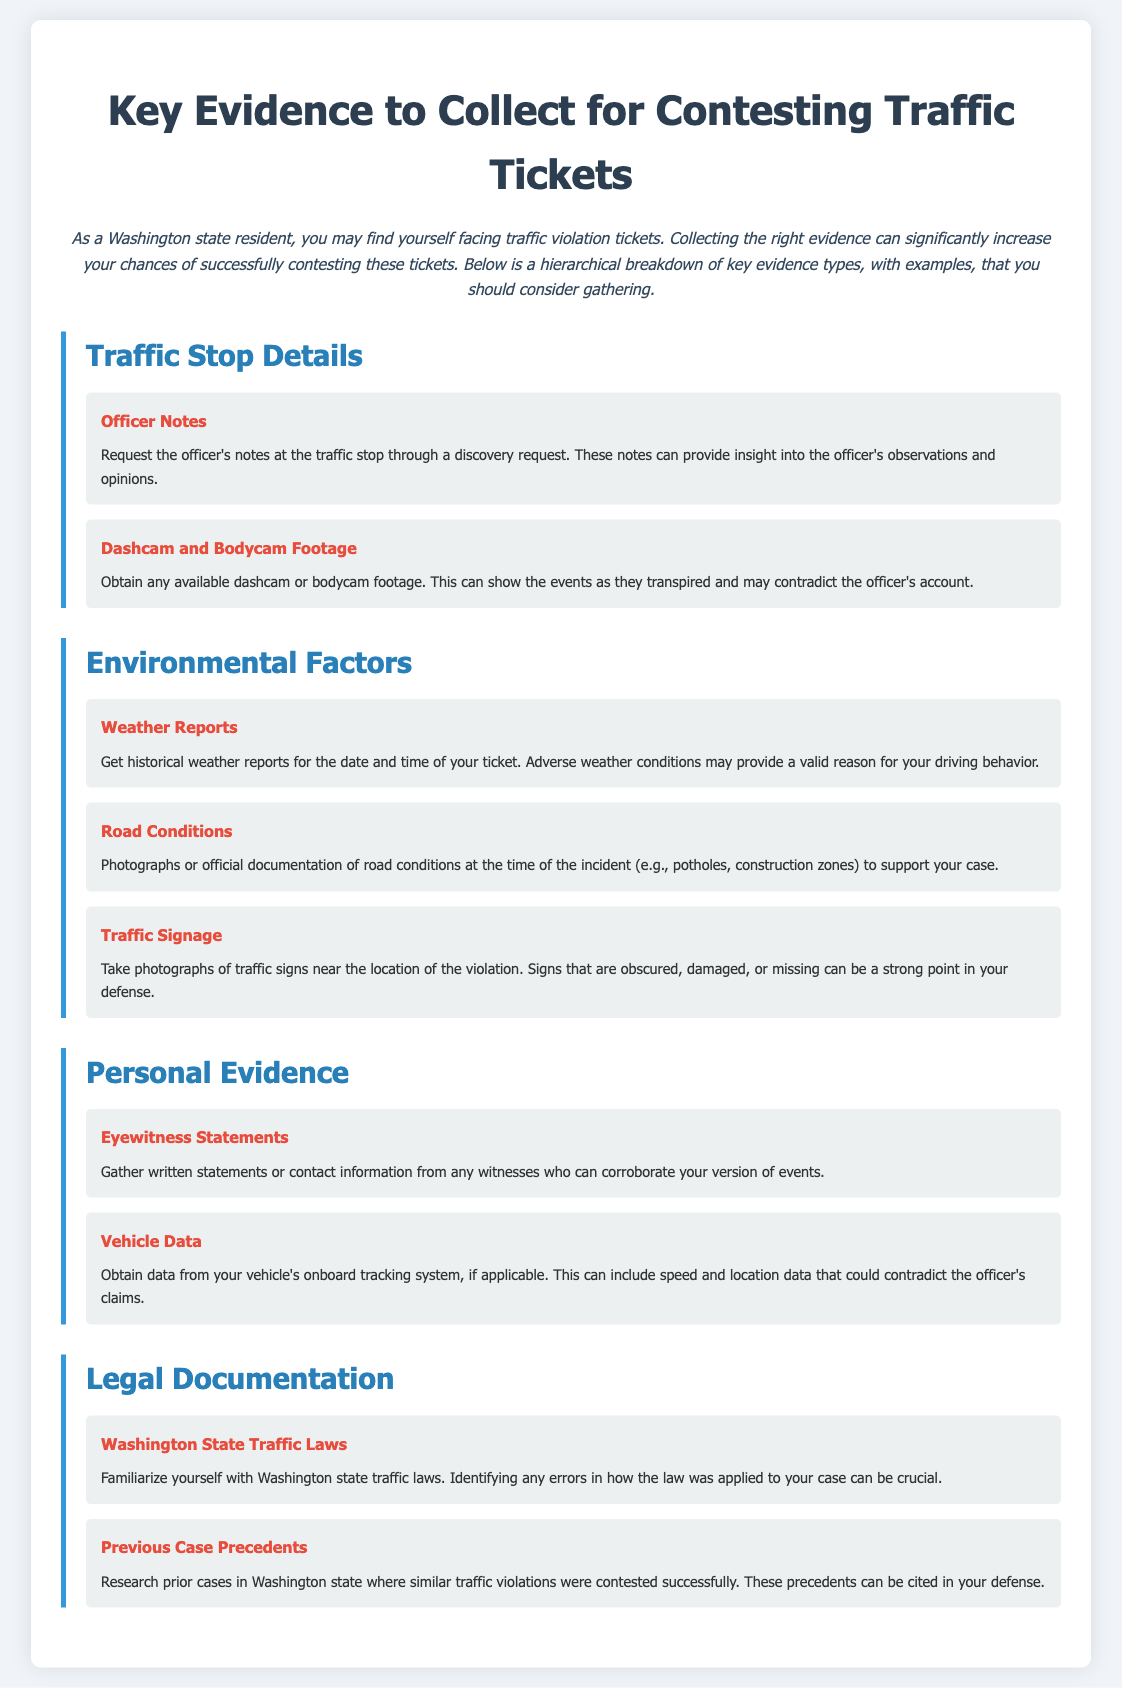What are two types of video evidence to collect? The document lists dashcam and bodycam footage as types of video evidence.
Answer: Dashcam, Bodycam footage What environmental factor can support your case regarding driving behavior? Historical weather reports can provide a valid reason for your driving behavior.
Answer: Weather Reports What type of evidence is suggested for corroborating your version of events? Eyewitness statements can support your claims about the incident.
Answer: Eyewitness Statements What should you familiarize yourself with regarding traffic tickets? Familiarizing yourself with Washington state traffic laws is crucial for your case.
Answer: Washington State Traffic Laws What type of documentation can be used to show road issues during the incident? Photographs or official documentation of road conditions can support your claim.
Answer: Road Conditions What aspect can you challenge if you find an error in its application? Errors in the application of Washington state traffic laws can be challenged.
Answer: Traffic Laws What is suggested for gathering witness information? Gathering written statements or contact information is recommended.
Answer: Eyewitness Statements 